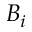Convert formula to latex. <formula><loc_0><loc_0><loc_500><loc_500>B _ { i }</formula> 